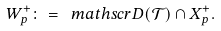<formula> <loc_0><loc_0><loc_500><loc_500>W _ { p } ^ { + } \colon = \ m a t h s c r { D } ( \mathcal { T } ) \cap X ^ { + } _ { p } .</formula> 